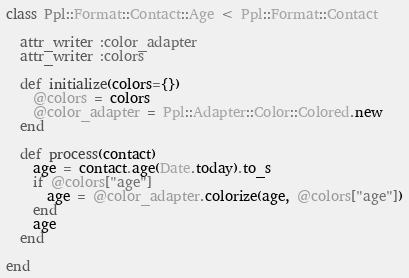Convert code to text. <code><loc_0><loc_0><loc_500><loc_500><_Ruby_>class Ppl::Format::Contact::Age < Ppl::Format::Contact

  attr_writer :color_adapter
  attr_writer :colors

  def initialize(colors={})
    @colors = colors
    @color_adapter = Ppl::Adapter::Color::Colored.new
  end

  def process(contact)
    age = contact.age(Date.today).to_s
    if @colors["age"]
      age = @color_adapter.colorize(age, @colors["age"])
    end
    age
  end

end

</code> 